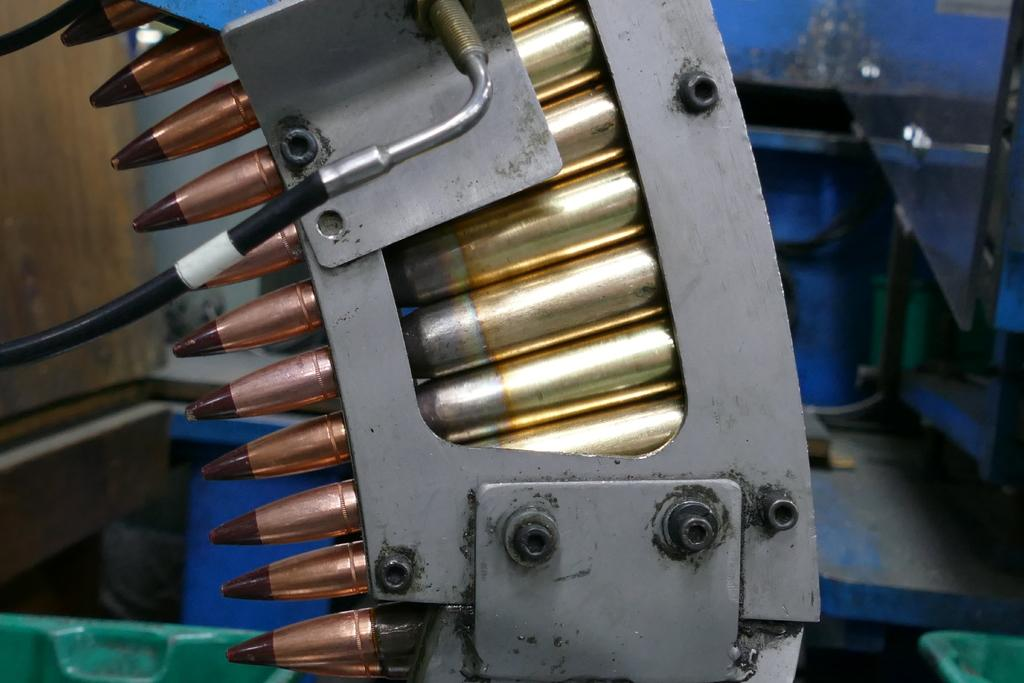What is inside the magazine in the image? There are bullets in the magazine in the image. What color are the bullets? The bullets are gold in color. What can be seen in the background of the image? There is a wall in the background of the image. What type of action can be seen taking place on the street in the image? There is no street or action present in the image; it only features a magazine with gold bullets and a wall in the background. 